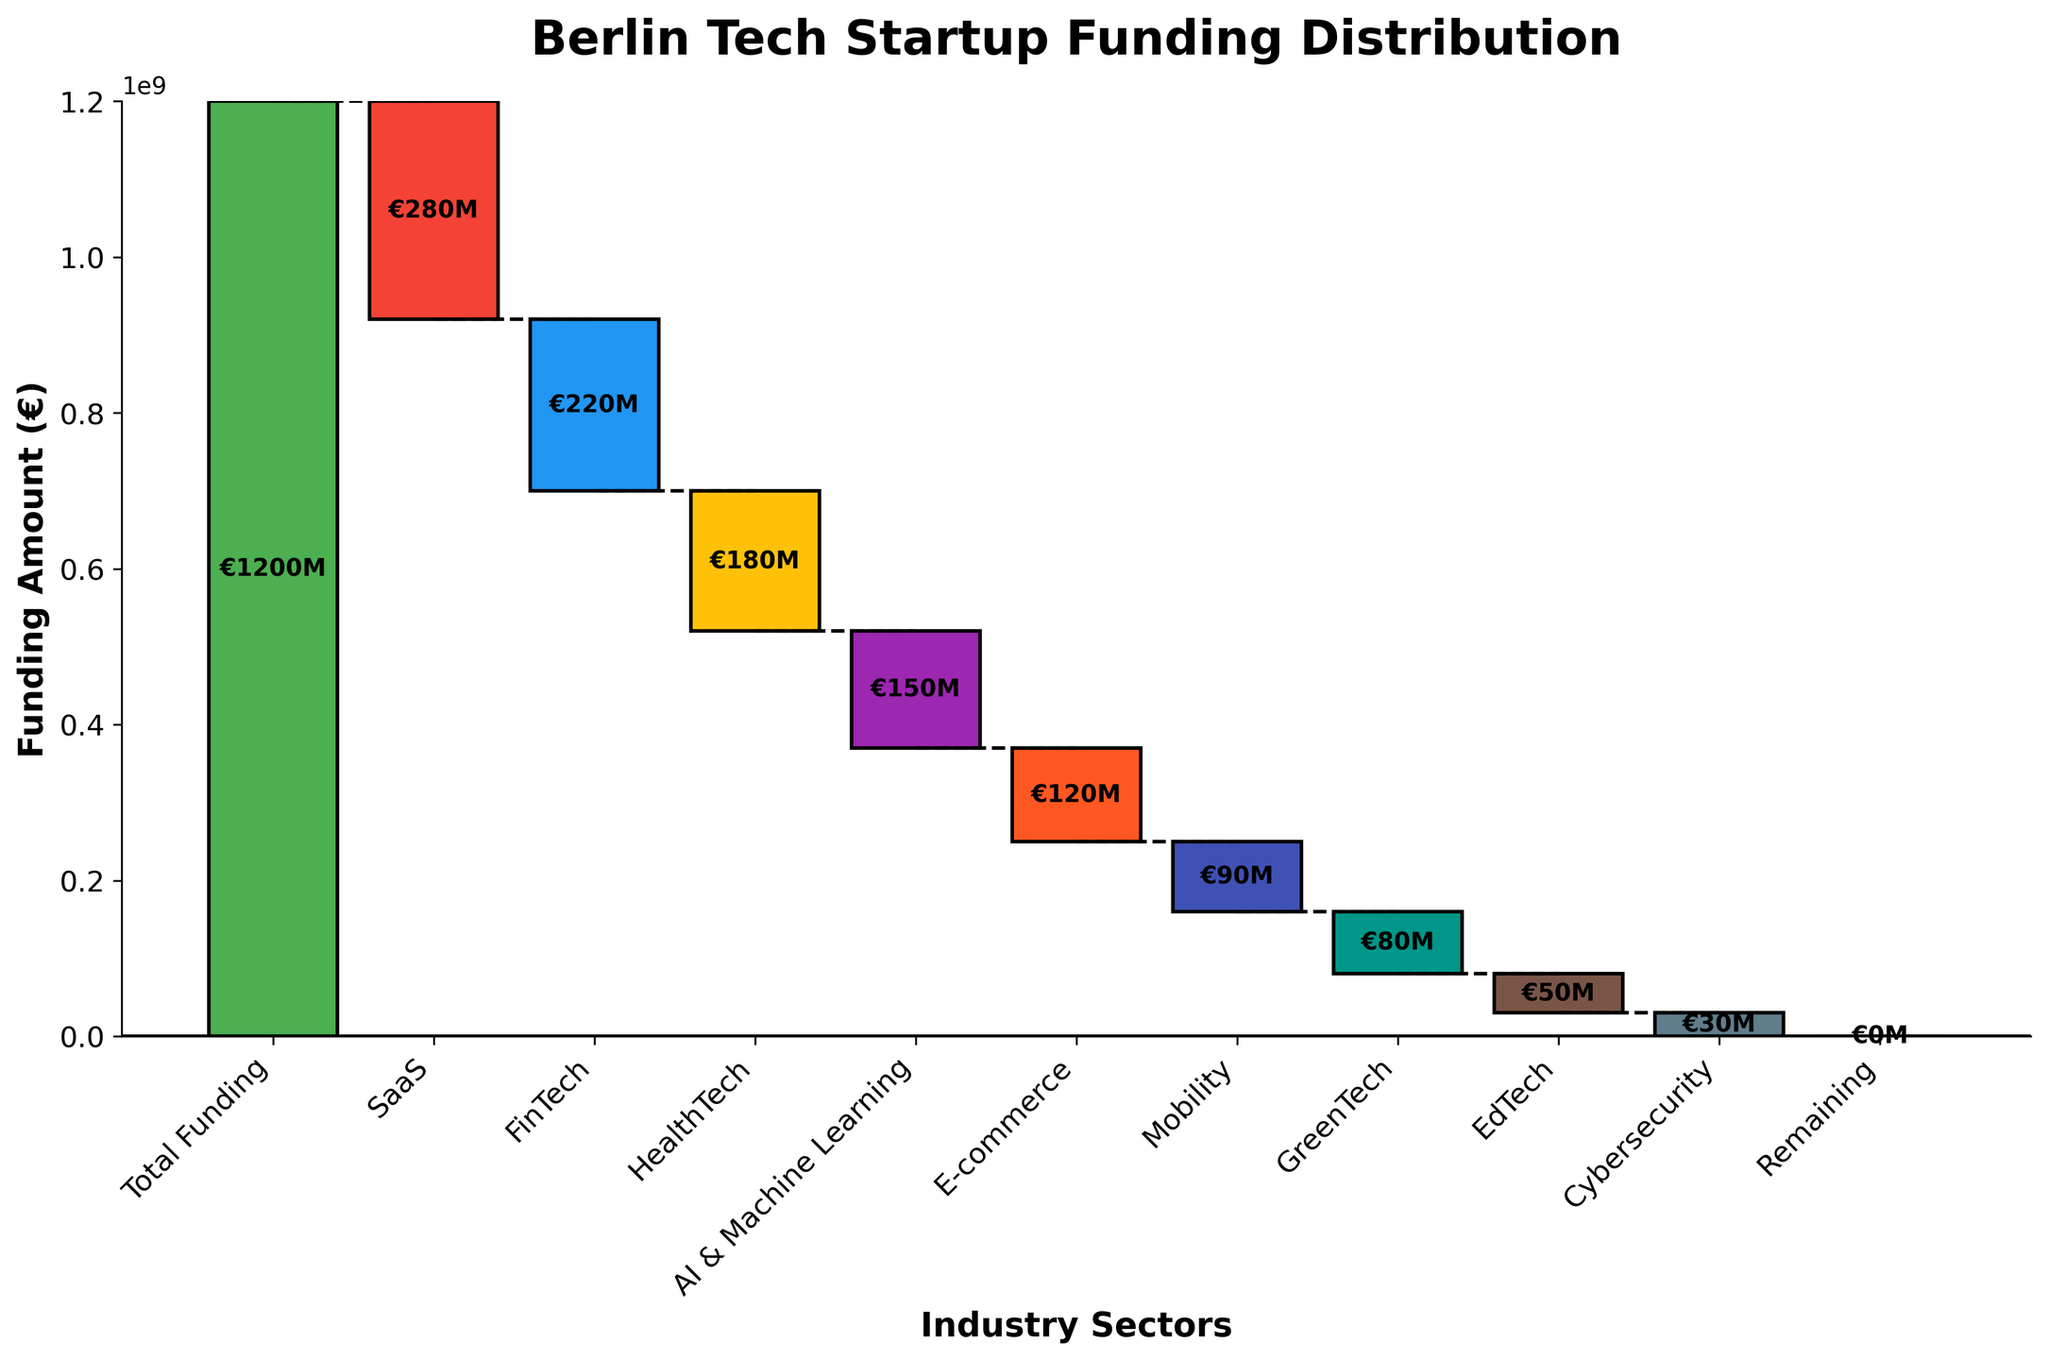What is the total amount of funding shown in the chart? Looking at the first bar at the top of the chart, it represents the total funding value.
Answer: €1,200M How much funding did the SaaS sector receive? The bar labeled "SaaS" shows its funding amount with the value annotated next to it.
Answer: -€280M Which industry sector received the least funding? By comparing the heights of all bars, the Cybersecurity sector has the smallest height, indicating the least funding.
Answer: Cybersecurity What is the combined funding for the HealthTech and FinTech sectors? Add the values from the HealthTech (-€180M) and FinTech (-€220M) bars together.
Answer: -€400M Which industry sector has a funding amount between GreenTech and AI & Machine Learning? Compare the vertical positions of the GreenTech, EdTech, and AI & Machine Learning bars to see that EdTech is in between them.
Answer: EdTech How does the funding for E-commerce compare to Mobility? Check the heights of their respective bars: Both are colored differently but E-commerce has a taller bar than Mobility.
Answer: E-commerce > Mobility What is the net funding for all sectors except the remaining category? Sum all funding values except the "Remaining" category and the "Total Funding". The calculation is: -€280M - €220M - €180M - €150M - €120M - €90M - €80M - €50M - €30M = -€1,200M.
Answer: -€1,200M What percentage of the total funding was allocated to FinTech? To find the percentage, divide the FinTech funding (-€220M) by the total funding (€1,200M) and multiply by 100. Calculation: (-€220M / €1,200M) * 100 = -18.33%.
Answer: -18.33% Which two sectors combined account for more than half of the total funding subtraction? The total funding subtracted by the top two subtracting sectors is: SaaS (-€280M) and FinTech (-€220M). Combined: -€280M + (-€220M) = -€500M, which is more than half of the total (€1,200M).
Answer: SaaS and FinTech At which point does the cumulative funding value reach €650M? Starting from €1,200M and sequentially subtracting the funding per sector in order, the cumulative value reaches €650M right after subtracting the HealthTech sector.
Answer: Right after HealthTech 